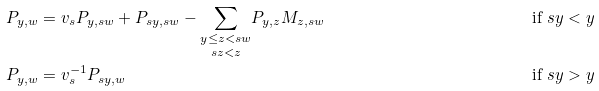Convert formula to latex. <formula><loc_0><loc_0><loc_500><loc_500>P _ { y , w } & = v _ { s } P _ { y , s w } + P _ { s y , s w } - \underset { s z < z } { \sum _ { y \leq z < s w } } P _ { y , z } M _ { z , s w } & \text {if $sy<y$} \\ P _ { y , w } & = v ^ { - 1 } _ { s } P _ { s y , w } & \text {if $sy>y$}</formula> 